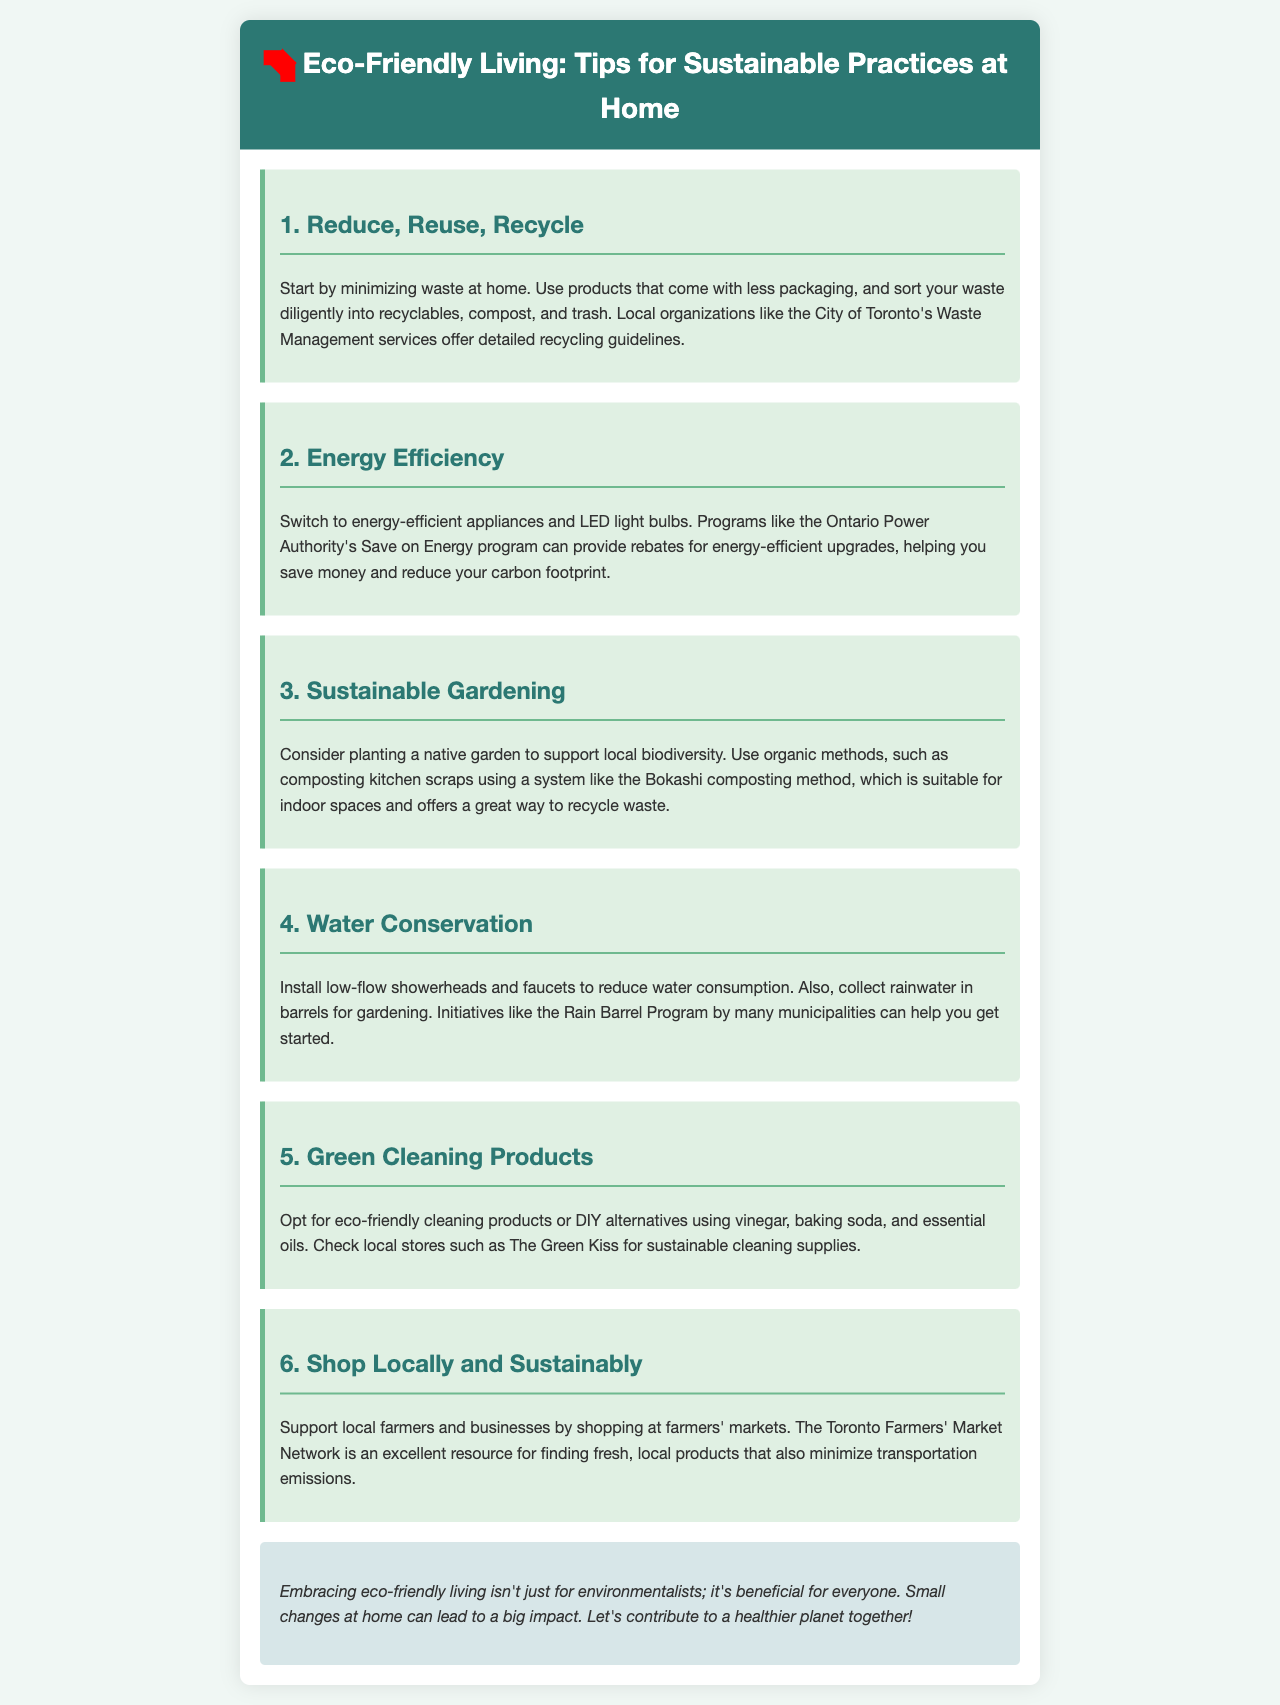What is the main title of the brochure? The title of the brochure is prominently displayed at the top of the document.
Answer: Eco-Friendly Living: Tips for Sustainable Practices at Home What is the first tip mentioned in the brochure? The first tip is outlined in a section with a heading.
Answer: Reduce, Reuse, Recycle What does the Ontario Power Authority's program offer? The document states that it provides specific benefits related to energy-efficient upgrades.
Answer: Rebates What gardening method is suggested for recycling waste? The brochure mentions an eco-friendly composting method suitable for indoor use.
Answer: Bokashi composting What color are the backgrounds of the tips sections? The color schemes are specified in the styling of the tips within the brochure.
Answer: Light green How can one reduce water consumption according to the brochure? The brochure provides a suggestion regarding specific fixtures to consider installing.
Answer: Low-flow showerheads and faucets What type of products does the document recommend for cleaning? The tip section addresses alternatives to traditional cleaning products.
Answer: Eco-friendly cleaning products Where can you shop for fresh, local products according to the brochure? The document mentions a specific marketplace that supports local farmers.
Answer: Farmers' markets What overall benefit does eco-friendly living provide? The conclusion of the brochure emphasizes the impact of the changes suggested.
Answer: A healthier planet 